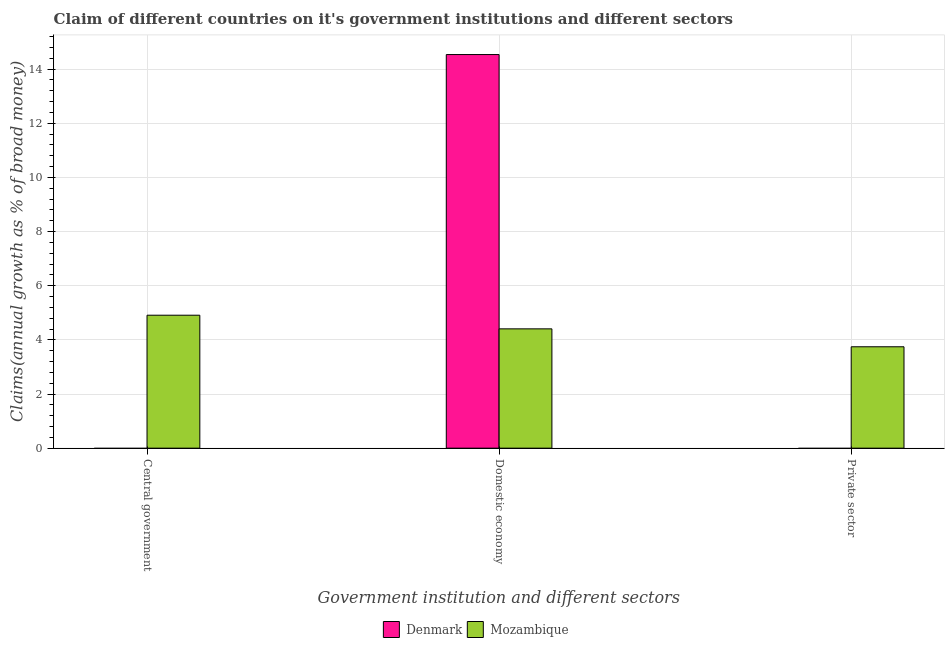How many different coloured bars are there?
Your answer should be very brief. 2. What is the label of the 1st group of bars from the left?
Provide a short and direct response. Central government. What is the percentage of claim on the central government in Mozambique?
Make the answer very short. 4.91. Across all countries, what is the maximum percentage of claim on the central government?
Provide a succinct answer. 4.91. In which country was the percentage of claim on the central government maximum?
Provide a succinct answer. Mozambique. What is the total percentage of claim on the private sector in the graph?
Your response must be concise. 3.75. What is the difference between the percentage of claim on the domestic economy in Mozambique and that in Denmark?
Your answer should be compact. -10.13. What is the difference between the percentage of claim on the private sector in Mozambique and the percentage of claim on the domestic economy in Denmark?
Give a very brief answer. -10.79. What is the average percentage of claim on the private sector per country?
Offer a very short reply. 1.87. What is the difference between the percentage of claim on the private sector and percentage of claim on the domestic economy in Mozambique?
Make the answer very short. -0.66. In how many countries, is the percentage of claim on the domestic economy greater than 12.8 %?
Make the answer very short. 1. What is the ratio of the percentage of claim on the domestic economy in Mozambique to that in Denmark?
Provide a succinct answer. 0.3. Is the percentage of claim on the domestic economy in Mozambique less than that in Denmark?
Offer a terse response. Yes. What is the difference between the highest and the second highest percentage of claim on the domestic economy?
Provide a succinct answer. 10.13. What is the difference between the highest and the lowest percentage of claim on the private sector?
Make the answer very short. 3.75. In how many countries, is the percentage of claim on the domestic economy greater than the average percentage of claim on the domestic economy taken over all countries?
Keep it short and to the point. 1. Is the sum of the percentage of claim on the domestic economy in Denmark and Mozambique greater than the maximum percentage of claim on the central government across all countries?
Your answer should be compact. Yes. How many countries are there in the graph?
Give a very brief answer. 2. Does the graph contain any zero values?
Your answer should be compact. Yes. Does the graph contain grids?
Provide a succinct answer. Yes. What is the title of the graph?
Keep it short and to the point. Claim of different countries on it's government institutions and different sectors. Does "Turkmenistan" appear as one of the legend labels in the graph?
Offer a terse response. No. What is the label or title of the X-axis?
Offer a terse response. Government institution and different sectors. What is the label or title of the Y-axis?
Make the answer very short. Claims(annual growth as % of broad money). What is the Claims(annual growth as % of broad money) in Mozambique in Central government?
Your answer should be very brief. 4.91. What is the Claims(annual growth as % of broad money) in Denmark in Domestic economy?
Offer a terse response. 14.54. What is the Claims(annual growth as % of broad money) of Mozambique in Domestic economy?
Offer a very short reply. 4.41. What is the Claims(annual growth as % of broad money) in Mozambique in Private sector?
Offer a very short reply. 3.75. Across all Government institution and different sectors, what is the maximum Claims(annual growth as % of broad money) of Denmark?
Your answer should be very brief. 14.54. Across all Government institution and different sectors, what is the maximum Claims(annual growth as % of broad money) of Mozambique?
Offer a terse response. 4.91. Across all Government institution and different sectors, what is the minimum Claims(annual growth as % of broad money) in Denmark?
Keep it short and to the point. 0. Across all Government institution and different sectors, what is the minimum Claims(annual growth as % of broad money) of Mozambique?
Your response must be concise. 3.75. What is the total Claims(annual growth as % of broad money) in Denmark in the graph?
Make the answer very short. 14.54. What is the total Claims(annual growth as % of broad money) of Mozambique in the graph?
Ensure brevity in your answer.  13.06. What is the difference between the Claims(annual growth as % of broad money) in Mozambique in Central government and that in Domestic economy?
Keep it short and to the point. 0.5. What is the difference between the Claims(annual growth as % of broad money) of Mozambique in Central government and that in Private sector?
Keep it short and to the point. 1.17. What is the difference between the Claims(annual growth as % of broad money) of Mozambique in Domestic economy and that in Private sector?
Provide a succinct answer. 0.66. What is the difference between the Claims(annual growth as % of broad money) of Denmark in Domestic economy and the Claims(annual growth as % of broad money) of Mozambique in Private sector?
Offer a terse response. 10.79. What is the average Claims(annual growth as % of broad money) of Denmark per Government institution and different sectors?
Your response must be concise. 4.85. What is the average Claims(annual growth as % of broad money) in Mozambique per Government institution and different sectors?
Make the answer very short. 4.35. What is the difference between the Claims(annual growth as % of broad money) of Denmark and Claims(annual growth as % of broad money) of Mozambique in Domestic economy?
Provide a short and direct response. 10.13. What is the ratio of the Claims(annual growth as % of broad money) in Mozambique in Central government to that in Domestic economy?
Your answer should be very brief. 1.11. What is the ratio of the Claims(annual growth as % of broad money) of Mozambique in Central government to that in Private sector?
Offer a very short reply. 1.31. What is the ratio of the Claims(annual growth as % of broad money) in Mozambique in Domestic economy to that in Private sector?
Provide a succinct answer. 1.18. What is the difference between the highest and the second highest Claims(annual growth as % of broad money) in Mozambique?
Your answer should be very brief. 0.5. What is the difference between the highest and the lowest Claims(annual growth as % of broad money) of Denmark?
Your answer should be compact. 14.54. What is the difference between the highest and the lowest Claims(annual growth as % of broad money) of Mozambique?
Your answer should be very brief. 1.17. 